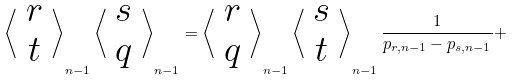<formula> <loc_0><loc_0><loc_500><loc_500>\left \langle \begin{array} { c c } r \\ t \end{array} \right \rangle _ { n - 1 } \left \langle \begin{array} { c c } s \\ q \end{array} \right \rangle _ { n - 1 } = \left \langle \begin{array} { c c } r \\ q \end{array} \right \rangle _ { n - 1 } \left \langle \begin{array} { c c } s \\ t \end{array} \right \rangle _ { n - 1 } \frac { 1 } { p _ { r , n - 1 } - p _ { s , n - 1 } } +</formula> 